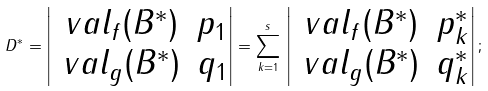Convert formula to latex. <formula><loc_0><loc_0><loc_500><loc_500>D ^ { * } = \left | \begin{matrix} \ v a l _ { f } ( B ^ { * } ) & p _ { 1 } \\ \ v a l _ { g } ( B ^ { * } ) & q _ { 1 } \end{matrix} \right | = \sum _ { k = 1 } ^ { s } \, \left | \begin{matrix} \ v a l _ { f } ( B ^ { * } ) & p _ { k } ^ { * } \\ \ v a l _ { g } ( B ^ { * } ) & q _ { k } ^ { * } \end{matrix} \right | ;</formula> 